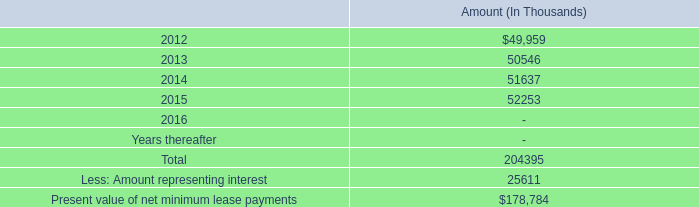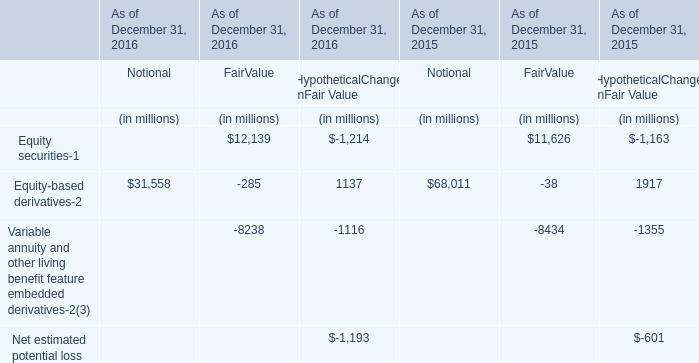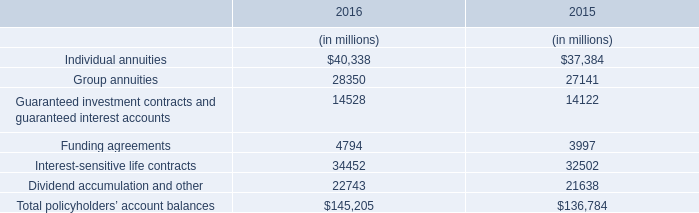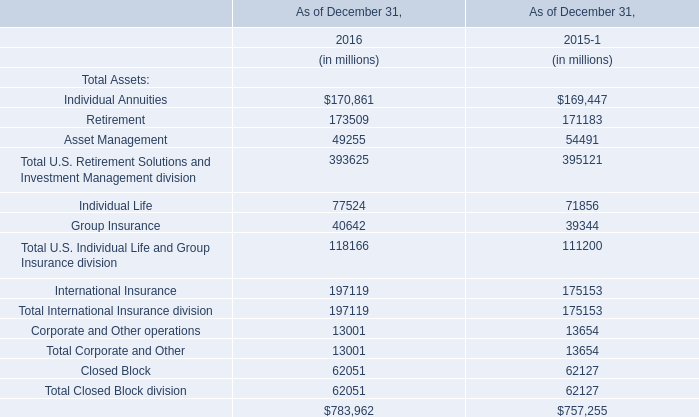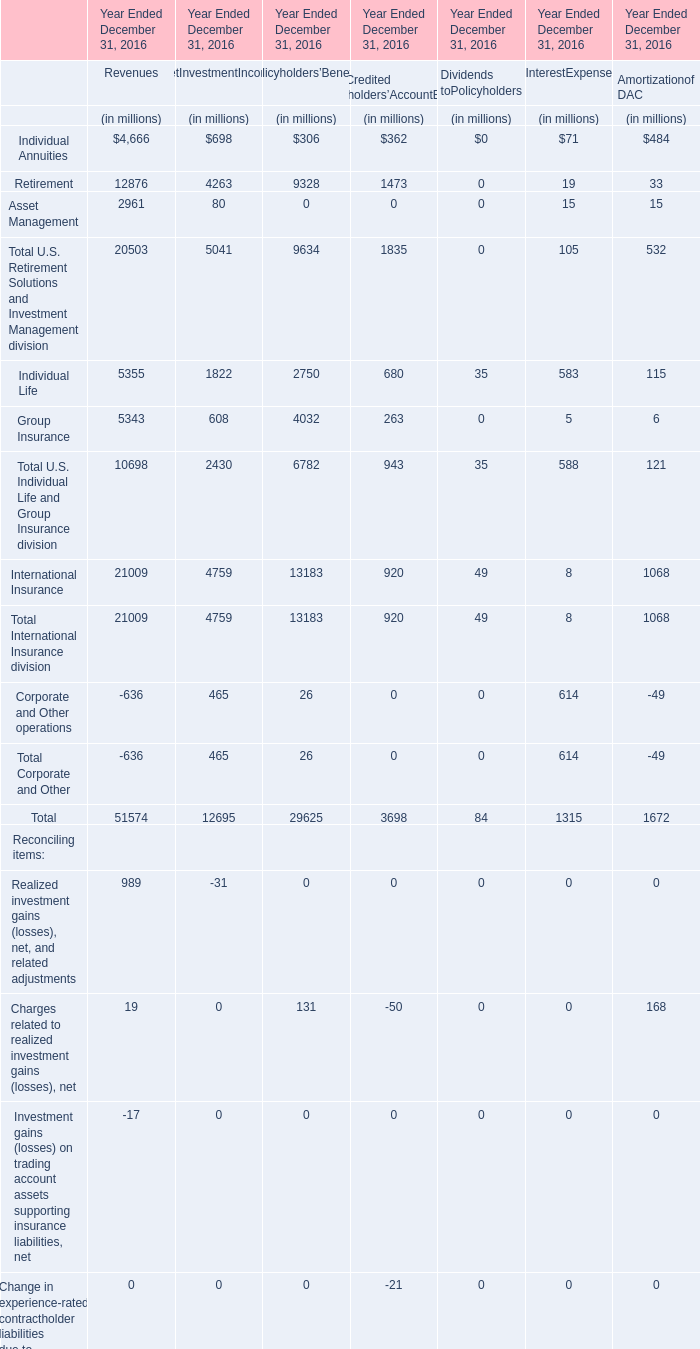What was the average value of Total U.S. Retirement Solutions and Investment Management division ,Retirement ,Asset Management forRevenues (in million) 
Computations: (((12876 + 2961) + 20503) / 3)
Answer: 12113.33333. 